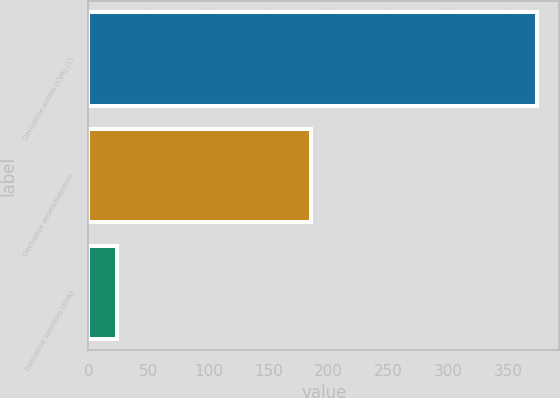Convert chart to OTSL. <chart><loc_0><loc_0><loc_500><loc_500><bar_chart><fcel>Derivative assets (CVA) (1)<fcel>Derivative assets/liabilities<fcel>Derivative liabilities (DVA)<nl><fcel>374<fcel>186<fcel>24<nl></chart> 